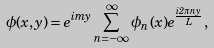<formula> <loc_0><loc_0><loc_500><loc_500>\phi ( x , y ) = e ^ { i m y } \sum _ { n = - \infty } ^ { \infty } { \phi } _ { n } ( x ) e ^ { \frac { i 2 { \pi } n y } { L } } ,</formula> 